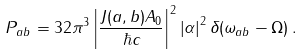<formula> <loc_0><loc_0><loc_500><loc_500>P _ { a b } = 3 2 \pi ^ { 3 } \left | \frac { J ( a , b ) A _ { 0 } } { \hbar { c } } \right | ^ { 2 } \left | \alpha \right | ^ { 2 } \delta ( \omega _ { a b } - \Omega ) \, .</formula> 